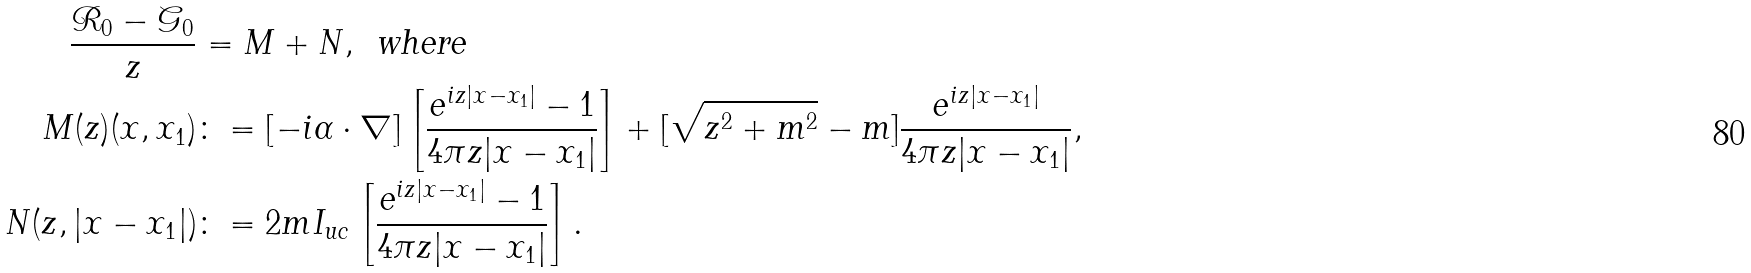Convert formula to latex. <formula><loc_0><loc_0><loc_500><loc_500>\frac { \mathcal { R } _ { 0 } - \mathcal { G } _ { 0 } } { z } & = M + N , \, \text { where} \\ M ( z ) ( x , x _ { 1 } ) & \colon = [ - i \alpha \cdot \nabla ] \left [ \frac { e ^ { i z | x - x _ { 1 } | } - 1 } { 4 \pi z | x - x _ { 1 } | } \right ] + [ \sqrt { z ^ { 2 } + m ^ { 2 } } - m ] \frac { e ^ { i z | x - x _ { 1 } | } } { 4 \pi z | x - x _ { 1 } | } , \\ N ( z , | x - x _ { 1 } | ) & \colon = 2 m I _ { u c } \left [ \frac { e ^ { i z | x - x _ { 1 } | } - 1 } { 4 \pi z | x - x _ { 1 } | } \right ] .</formula> 